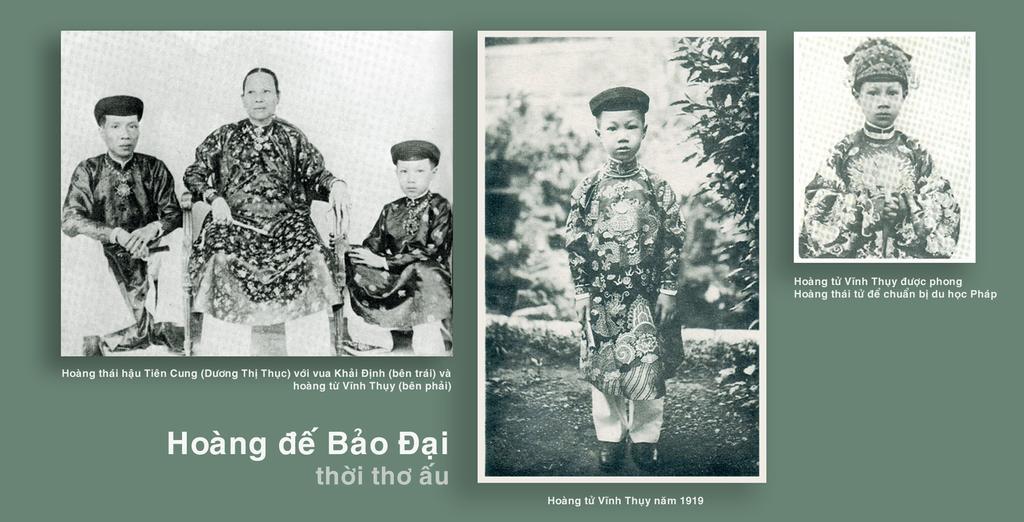Please provide a concise description of this image. In this image we can see a black and white collage pictures of a person's. 